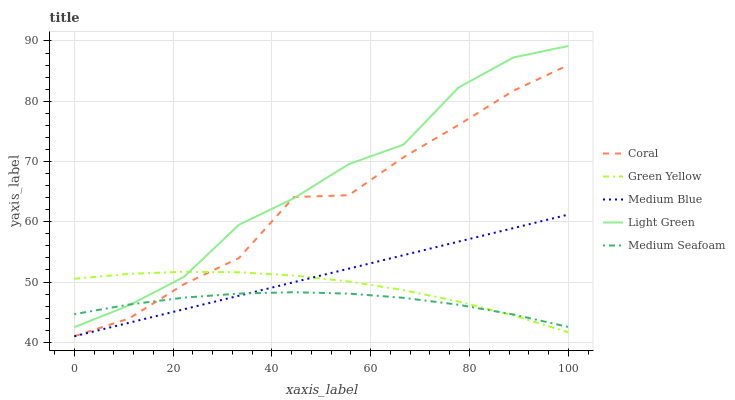Does Medium Seafoam have the minimum area under the curve?
Answer yes or no. Yes. Does Light Green have the maximum area under the curve?
Answer yes or no. Yes. Does Green Yellow have the minimum area under the curve?
Answer yes or no. No. Does Green Yellow have the maximum area under the curve?
Answer yes or no. No. Is Medium Blue the smoothest?
Answer yes or no. Yes. Is Coral the roughest?
Answer yes or no. Yes. Is Green Yellow the smoothest?
Answer yes or no. No. Is Green Yellow the roughest?
Answer yes or no. No. Does Coral have the lowest value?
Answer yes or no. Yes. Does Green Yellow have the lowest value?
Answer yes or no. No. Does Light Green have the highest value?
Answer yes or no. Yes. Does Green Yellow have the highest value?
Answer yes or no. No. Is Medium Blue less than Light Green?
Answer yes or no. Yes. Is Light Green greater than Medium Blue?
Answer yes or no. Yes. Does Coral intersect Medium Blue?
Answer yes or no. Yes. Is Coral less than Medium Blue?
Answer yes or no. No. Is Coral greater than Medium Blue?
Answer yes or no. No. Does Medium Blue intersect Light Green?
Answer yes or no. No. 